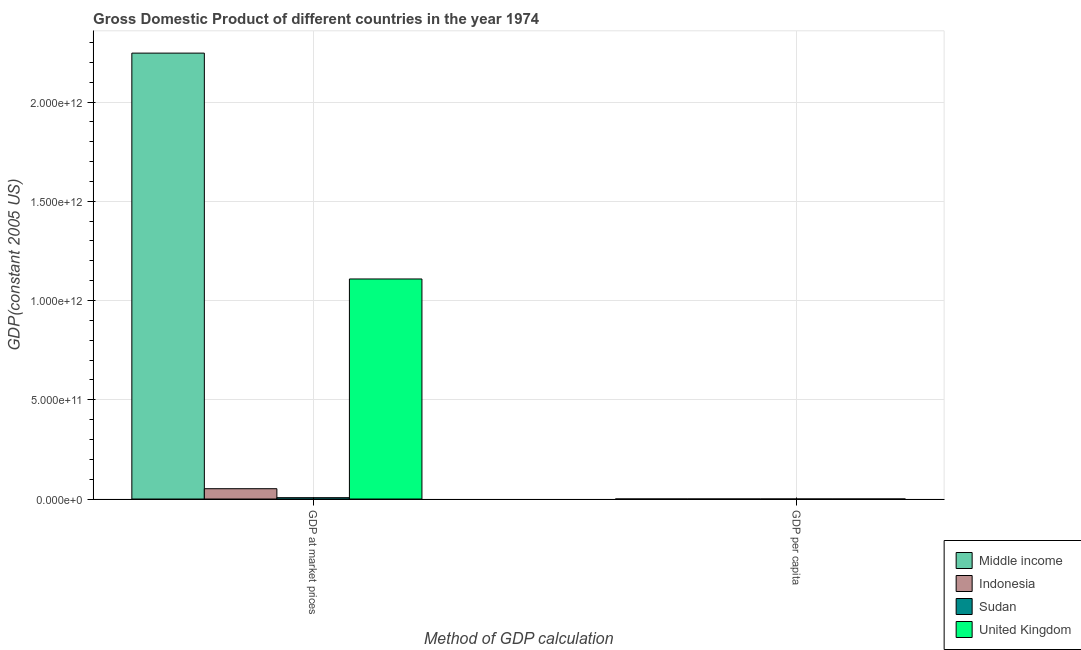How many groups of bars are there?
Your answer should be compact. 2. Are the number of bars per tick equal to the number of legend labels?
Offer a very short reply. Yes. Are the number of bars on each tick of the X-axis equal?
Provide a succinct answer. Yes. How many bars are there on the 2nd tick from the right?
Offer a terse response. 4. What is the label of the 2nd group of bars from the left?
Your answer should be very brief. GDP per capita. What is the gdp per capita in Middle income?
Offer a terse response. 827.87. Across all countries, what is the maximum gdp per capita?
Your answer should be very brief. 1.97e+04. Across all countries, what is the minimum gdp at market prices?
Your answer should be very brief. 6.81e+09. In which country was the gdp at market prices maximum?
Your response must be concise. Middle income. In which country was the gdp per capita minimum?
Make the answer very short. Indonesia. What is the total gdp per capita in the graph?
Your answer should be very brief. 2.14e+04. What is the difference between the gdp at market prices in United Kingdom and that in Middle income?
Make the answer very short. -1.14e+12. What is the difference between the gdp per capita in Middle income and the gdp at market prices in Sudan?
Keep it short and to the point. -6.81e+09. What is the average gdp at market prices per country?
Make the answer very short. 8.53e+11. What is the difference between the gdp at market prices and gdp per capita in Sudan?
Provide a short and direct response. 6.81e+09. In how many countries, is the gdp per capita greater than 1800000000000 US$?
Provide a short and direct response. 0. What is the ratio of the gdp per capita in Indonesia to that in United Kingdom?
Provide a succinct answer. 0.02. Is the gdp at market prices in Middle income less than that in United Kingdom?
Give a very brief answer. No. How many bars are there?
Your answer should be compact. 8. Are all the bars in the graph horizontal?
Offer a terse response. No. How many countries are there in the graph?
Provide a succinct answer. 4. What is the difference between two consecutive major ticks on the Y-axis?
Keep it short and to the point. 5.00e+11. Where does the legend appear in the graph?
Your answer should be very brief. Bottom right. How many legend labels are there?
Your answer should be very brief. 4. How are the legend labels stacked?
Your answer should be compact. Vertical. What is the title of the graph?
Your answer should be compact. Gross Domestic Product of different countries in the year 1974. What is the label or title of the X-axis?
Give a very brief answer. Method of GDP calculation. What is the label or title of the Y-axis?
Your response must be concise. GDP(constant 2005 US). What is the GDP(constant 2005 US) of Middle income in GDP at market prices?
Your response must be concise. 2.25e+12. What is the GDP(constant 2005 US) in Indonesia in GDP at market prices?
Provide a short and direct response. 5.20e+1. What is the GDP(constant 2005 US) in Sudan in GDP at market prices?
Offer a terse response. 6.81e+09. What is the GDP(constant 2005 US) of United Kingdom in GDP at market prices?
Keep it short and to the point. 1.11e+12. What is the GDP(constant 2005 US) in Middle income in GDP per capita?
Make the answer very short. 827.87. What is the GDP(constant 2005 US) of Indonesia in GDP per capita?
Your answer should be compact. 408.18. What is the GDP(constant 2005 US) of Sudan in GDP per capita?
Offer a terse response. 434.16. What is the GDP(constant 2005 US) of United Kingdom in GDP per capita?
Give a very brief answer. 1.97e+04. Across all Method of GDP calculation, what is the maximum GDP(constant 2005 US) in Middle income?
Your response must be concise. 2.25e+12. Across all Method of GDP calculation, what is the maximum GDP(constant 2005 US) in Indonesia?
Your answer should be compact. 5.20e+1. Across all Method of GDP calculation, what is the maximum GDP(constant 2005 US) in Sudan?
Ensure brevity in your answer.  6.81e+09. Across all Method of GDP calculation, what is the maximum GDP(constant 2005 US) of United Kingdom?
Provide a short and direct response. 1.11e+12. Across all Method of GDP calculation, what is the minimum GDP(constant 2005 US) of Middle income?
Your answer should be compact. 827.87. Across all Method of GDP calculation, what is the minimum GDP(constant 2005 US) in Indonesia?
Your answer should be very brief. 408.18. Across all Method of GDP calculation, what is the minimum GDP(constant 2005 US) in Sudan?
Your response must be concise. 434.16. Across all Method of GDP calculation, what is the minimum GDP(constant 2005 US) in United Kingdom?
Keep it short and to the point. 1.97e+04. What is the total GDP(constant 2005 US) of Middle income in the graph?
Offer a very short reply. 2.25e+12. What is the total GDP(constant 2005 US) in Indonesia in the graph?
Give a very brief answer. 5.20e+1. What is the total GDP(constant 2005 US) of Sudan in the graph?
Offer a very short reply. 6.81e+09. What is the total GDP(constant 2005 US) in United Kingdom in the graph?
Offer a very short reply. 1.11e+12. What is the difference between the GDP(constant 2005 US) in Middle income in GDP at market prices and that in GDP per capita?
Give a very brief answer. 2.25e+12. What is the difference between the GDP(constant 2005 US) in Indonesia in GDP at market prices and that in GDP per capita?
Provide a short and direct response. 5.20e+1. What is the difference between the GDP(constant 2005 US) in Sudan in GDP at market prices and that in GDP per capita?
Provide a short and direct response. 6.81e+09. What is the difference between the GDP(constant 2005 US) in United Kingdom in GDP at market prices and that in GDP per capita?
Your answer should be compact. 1.11e+12. What is the difference between the GDP(constant 2005 US) of Middle income in GDP at market prices and the GDP(constant 2005 US) of Indonesia in GDP per capita?
Ensure brevity in your answer.  2.25e+12. What is the difference between the GDP(constant 2005 US) of Middle income in GDP at market prices and the GDP(constant 2005 US) of Sudan in GDP per capita?
Your answer should be compact. 2.25e+12. What is the difference between the GDP(constant 2005 US) in Middle income in GDP at market prices and the GDP(constant 2005 US) in United Kingdom in GDP per capita?
Your answer should be compact. 2.25e+12. What is the difference between the GDP(constant 2005 US) in Indonesia in GDP at market prices and the GDP(constant 2005 US) in Sudan in GDP per capita?
Ensure brevity in your answer.  5.20e+1. What is the difference between the GDP(constant 2005 US) of Indonesia in GDP at market prices and the GDP(constant 2005 US) of United Kingdom in GDP per capita?
Your response must be concise. 5.20e+1. What is the difference between the GDP(constant 2005 US) of Sudan in GDP at market prices and the GDP(constant 2005 US) of United Kingdom in GDP per capita?
Your answer should be compact. 6.81e+09. What is the average GDP(constant 2005 US) of Middle income per Method of GDP calculation?
Keep it short and to the point. 1.12e+12. What is the average GDP(constant 2005 US) in Indonesia per Method of GDP calculation?
Ensure brevity in your answer.  2.60e+1. What is the average GDP(constant 2005 US) of Sudan per Method of GDP calculation?
Ensure brevity in your answer.  3.40e+09. What is the average GDP(constant 2005 US) of United Kingdom per Method of GDP calculation?
Provide a succinct answer. 5.54e+11. What is the difference between the GDP(constant 2005 US) of Middle income and GDP(constant 2005 US) of Indonesia in GDP at market prices?
Keep it short and to the point. 2.19e+12. What is the difference between the GDP(constant 2005 US) of Middle income and GDP(constant 2005 US) of Sudan in GDP at market prices?
Ensure brevity in your answer.  2.24e+12. What is the difference between the GDP(constant 2005 US) of Middle income and GDP(constant 2005 US) of United Kingdom in GDP at market prices?
Offer a terse response. 1.14e+12. What is the difference between the GDP(constant 2005 US) in Indonesia and GDP(constant 2005 US) in Sudan in GDP at market prices?
Make the answer very short. 4.52e+1. What is the difference between the GDP(constant 2005 US) of Indonesia and GDP(constant 2005 US) of United Kingdom in GDP at market prices?
Provide a succinct answer. -1.06e+12. What is the difference between the GDP(constant 2005 US) in Sudan and GDP(constant 2005 US) in United Kingdom in GDP at market prices?
Ensure brevity in your answer.  -1.10e+12. What is the difference between the GDP(constant 2005 US) of Middle income and GDP(constant 2005 US) of Indonesia in GDP per capita?
Keep it short and to the point. 419.69. What is the difference between the GDP(constant 2005 US) of Middle income and GDP(constant 2005 US) of Sudan in GDP per capita?
Offer a very short reply. 393.72. What is the difference between the GDP(constant 2005 US) of Middle income and GDP(constant 2005 US) of United Kingdom in GDP per capita?
Keep it short and to the point. -1.89e+04. What is the difference between the GDP(constant 2005 US) in Indonesia and GDP(constant 2005 US) in Sudan in GDP per capita?
Keep it short and to the point. -25.98. What is the difference between the GDP(constant 2005 US) in Indonesia and GDP(constant 2005 US) in United Kingdom in GDP per capita?
Your answer should be very brief. -1.93e+04. What is the difference between the GDP(constant 2005 US) of Sudan and GDP(constant 2005 US) of United Kingdom in GDP per capita?
Offer a very short reply. -1.93e+04. What is the ratio of the GDP(constant 2005 US) in Middle income in GDP at market prices to that in GDP per capita?
Your answer should be compact. 2.71e+09. What is the ratio of the GDP(constant 2005 US) in Indonesia in GDP at market prices to that in GDP per capita?
Offer a very short reply. 1.27e+08. What is the ratio of the GDP(constant 2005 US) in Sudan in GDP at market prices to that in GDP per capita?
Offer a very short reply. 1.57e+07. What is the ratio of the GDP(constant 2005 US) of United Kingdom in GDP at market prices to that in GDP per capita?
Make the answer very short. 5.62e+07. What is the difference between the highest and the second highest GDP(constant 2005 US) of Middle income?
Give a very brief answer. 2.25e+12. What is the difference between the highest and the second highest GDP(constant 2005 US) in Indonesia?
Provide a short and direct response. 5.20e+1. What is the difference between the highest and the second highest GDP(constant 2005 US) in Sudan?
Make the answer very short. 6.81e+09. What is the difference between the highest and the second highest GDP(constant 2005 US) in United Kingdom?
Make the answer very short. 1.11e+12. What is the difference between the highest and the lowest GDP(constant 2005 US) of Middle income?
Your answer should be very brief. 2.25e+12. What is the difference between the highest and the lowest GDP(constant 2005 US) in Indonesia?
Keep it short and to the point. 5.20e+1. What is the difference between the highest and the lowest GDP(constant 2005 US) in Sudan?
Provide a succinct answer. 6.81e+09. What is the difference between the highest and the lowest GDP(constant 2005 US) in United Kingdom?
Offer a terse response. 1.11e+12. 